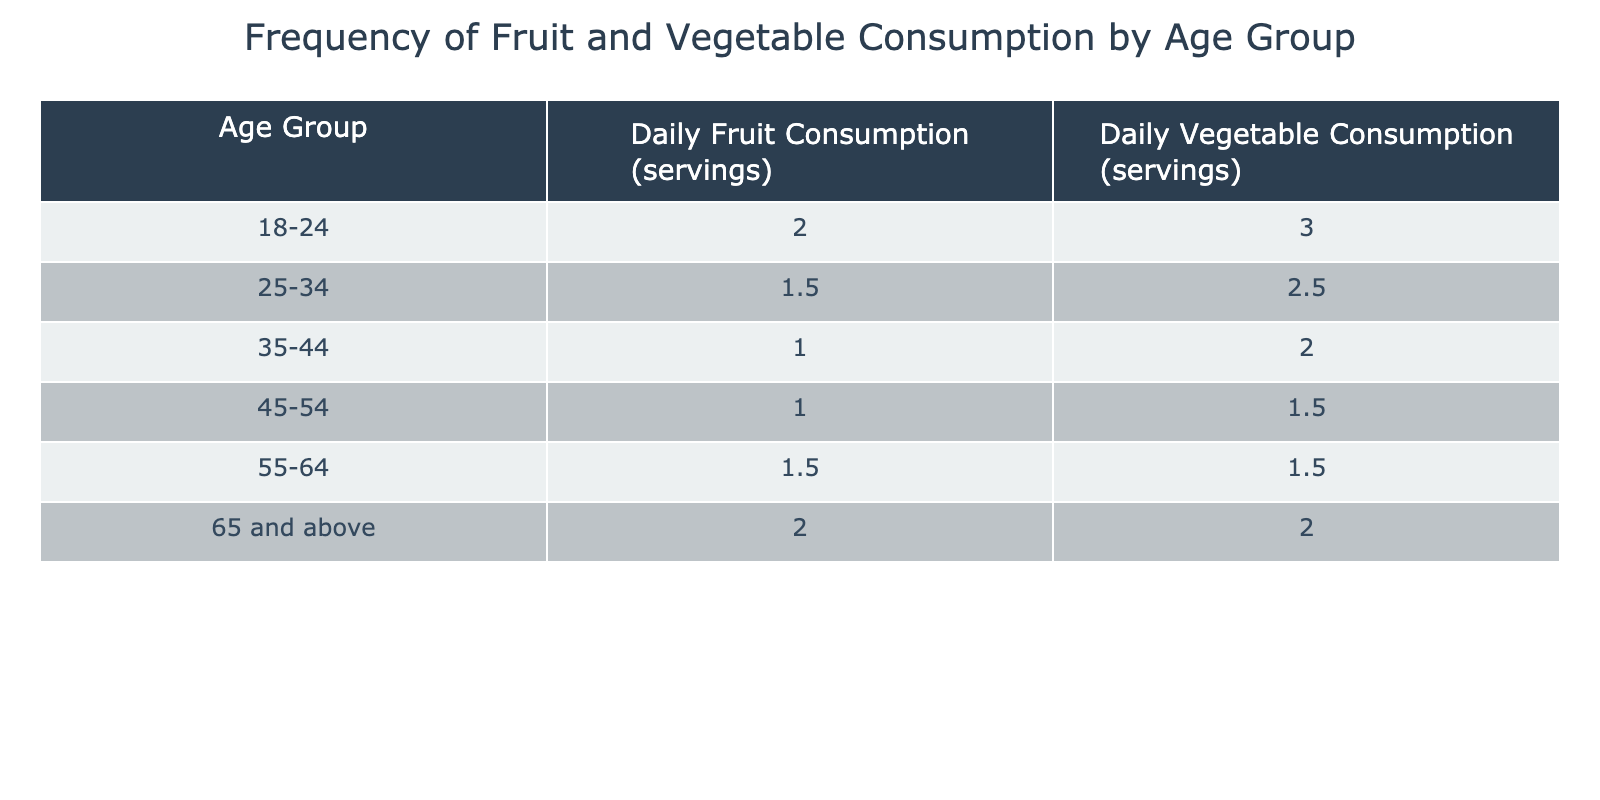What is the average daily fruit consumption for the 45-54 age group? The table provides the daily fruit consumption for the 45-54 age group as 1 serving. Since there is only one value for this group, the average is simply that same value.
Answer: 1 serving Which age group consumes the most vegetables daily? Reviewing the daily vegetable consumption across all age groups, the maximum value is 3 servings, which belongs to the 18-24 age group. Therefore, they consume the most vegetables daily.
Answer: 18-24 age group How does the daily fruit consumption of the 55-64 age group compare to that of the 35-44 age group? The daily fruit consumption for the 55-64 age group is 1.5 servings, while for the 35-44 age group it is 1 serving. Comparing these values shows that 1.5 is greater than 1.
Answer: 55-64 age group consumes more Is the average vegetable consumption for age groups 45-54 and 65 and above the same? The average vegetable consumption for the 45-54 age group is 1.5 servings and for the 65 and above age group is 2 servings. Comparing these two values, we find that they are not the same.
Answer: No What is the combined daily consumption of fruits and vegetables for the 25-34 age group? The daily fruit consumption for the 25-34 age group is 1.5 servings, and the vegetable consumption is 2.5 servings. Adding these two values together (1.5 + 2.5) gives us a total of 4 servings.
Answer: 4 servings Which age group has the lowest total consumption of fruits and vegetables combined? To find the lowest total consumption, we can calculate the total for each age group. The totals are: 18-24 (5), 25-34 (4), 35-44 (3), 45-54 (2.5), 55-64 (3), and 65 and above (4). The 45-54 age group has the lowest total at 2.5 servings.
Answer: 45-54 age group Is it true that all age groups consume at least 1 serving of fruits daily? Looking at the table, we can see that all age groups report at least 1 serving of fruit consumption. Thus, this statement is true considering all data points.
Answer: Yes What is the difference in daily vegetable consumption between the youngest and oldest age groups? The 18-24 age group consumes 3 servings of vegetables daily, while the 65 and above age group consumes 2 servings. The difference is calculated as 3 - 2 = 1 serving.
Answer: 1 serving 